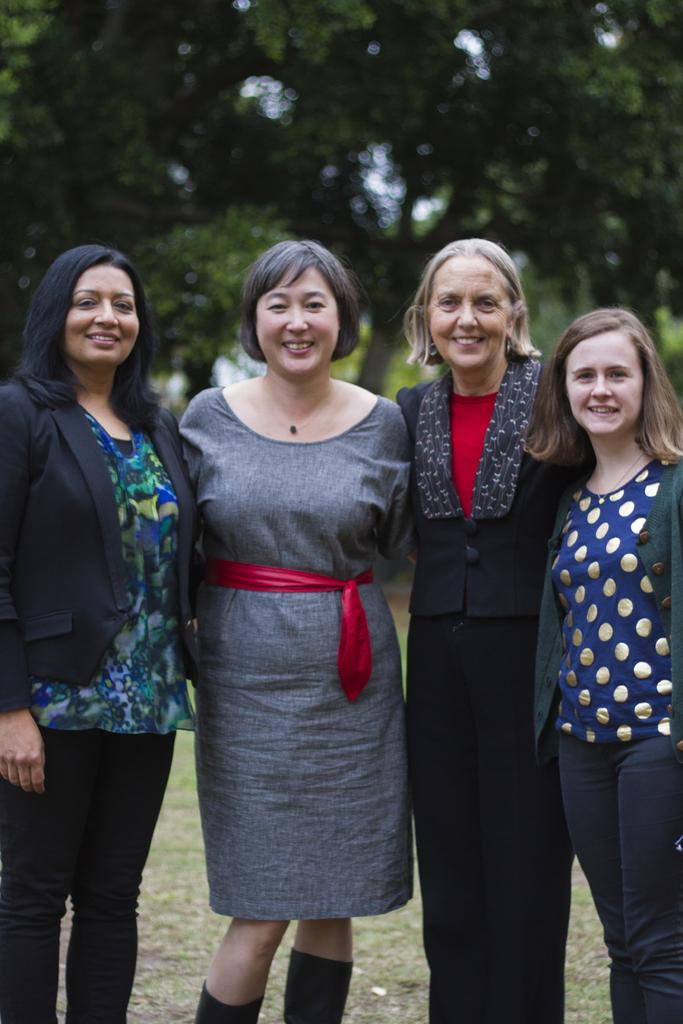How many people are in the image? There are four women in the image. What are the women doing in the image? The women are standing and smiling. What can be seen in the background of the image? There are trees in the background of the image. What type of pest can be seen crawling on the women's faces in the image? There are no pests visible on the women's faces in the image. How does the powder help the women in the image? There is no mention of powder in the image, so it cannot be determined how it might help the women. 